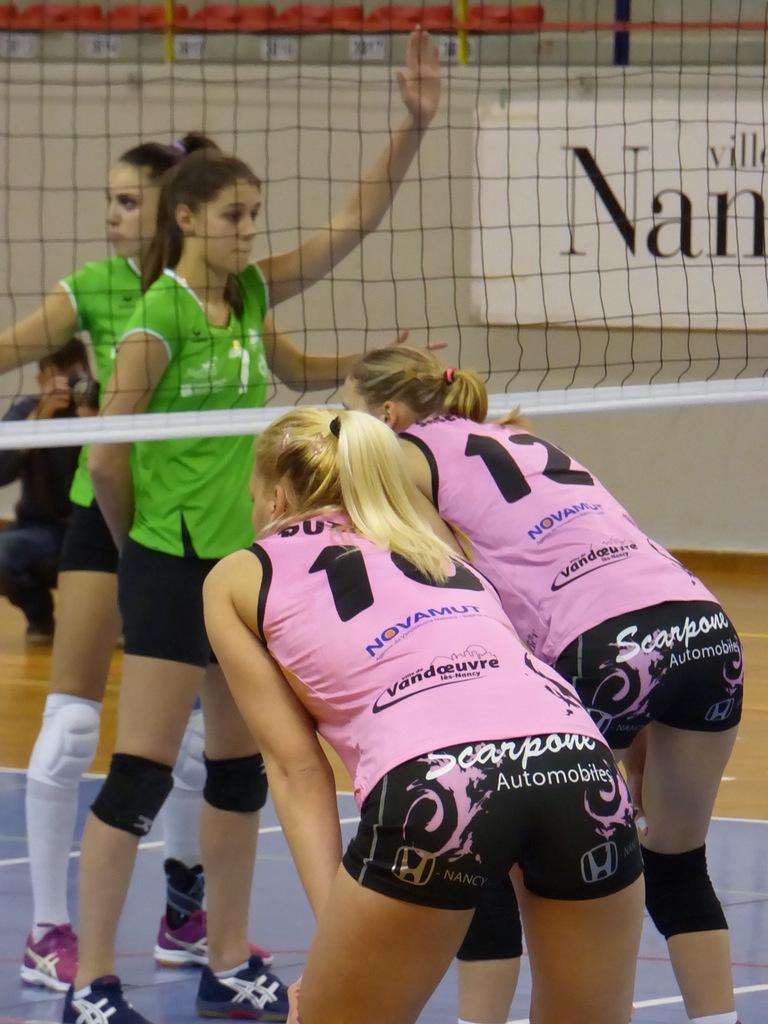What is the number of the girl on the right?
Provide a short and direct response. 12. Which automobile company sponsored the shorts?
Keep it short and to the point. Scarpone. 